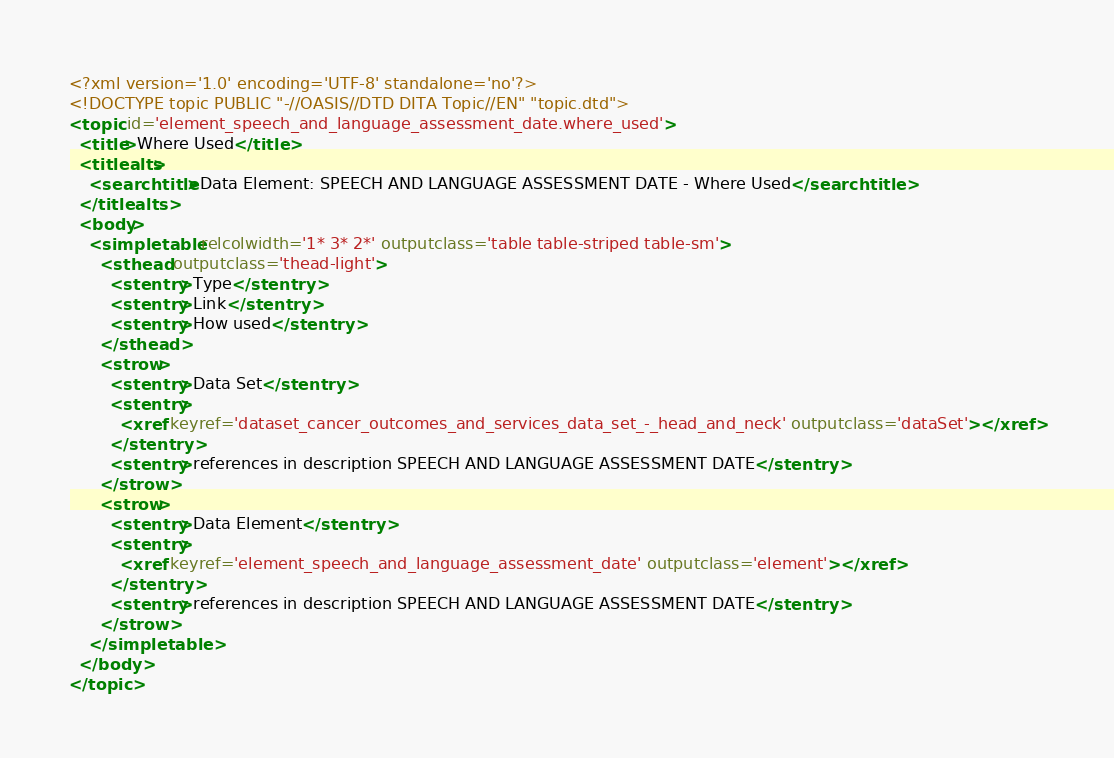<code> <loc_0><loc_0><loc_500><loc_500><_XML_><?xml version='1.0' encoding='UTF-8' standalone='no'?>
<!DOCTYPE topic PUBLIC "-//OASIS//DTD DITA Topic//EN" "topic.dtd">
<topic id='element_speech_and_language_assessment_date.where_used'>
  <title>Where Used</title>
  <titlealts>
    <searchtitle>Data Element: SPEECH AND LANGUAGE ASSESSMENT DATE - Where Used</searchtitle>
  </titlealts>
  <body>
    <simpletable relcolwidth='1* 3* 2*' outputclass='table table-striped table-sm'>
      <sthead outputclass='thead-light'>
        <stentry>Type</stentry>
        <stentry>Link</stentry>
        <stentry>How used</stentry>
      </sthead>
      <strow>
        <stentry>Data Set</stentry>
        <stentry>
          <xref keyref='dataset_cancer_outcomes_and_services_data_set_-_head_and_neck' outputclass='dataSet'></xref>
        </stentry>
        <stentry>references in description SPEECH AND LANGUAGE ASSESSMENT DATE</stentry>
      </strow>
      <strow>
        <stentry>Data Element</stentry>
        <stentry>
          <xref keyref='element_speech_and_language_assessment_date' outputclass='element'></xref>
        </stentry>
        <stentry>references in description SPEECH AND LANGUAGE ASSESSMENT DATE</stentry>
      </strow>
    </simpletable>
  </body>
</topic></code> 